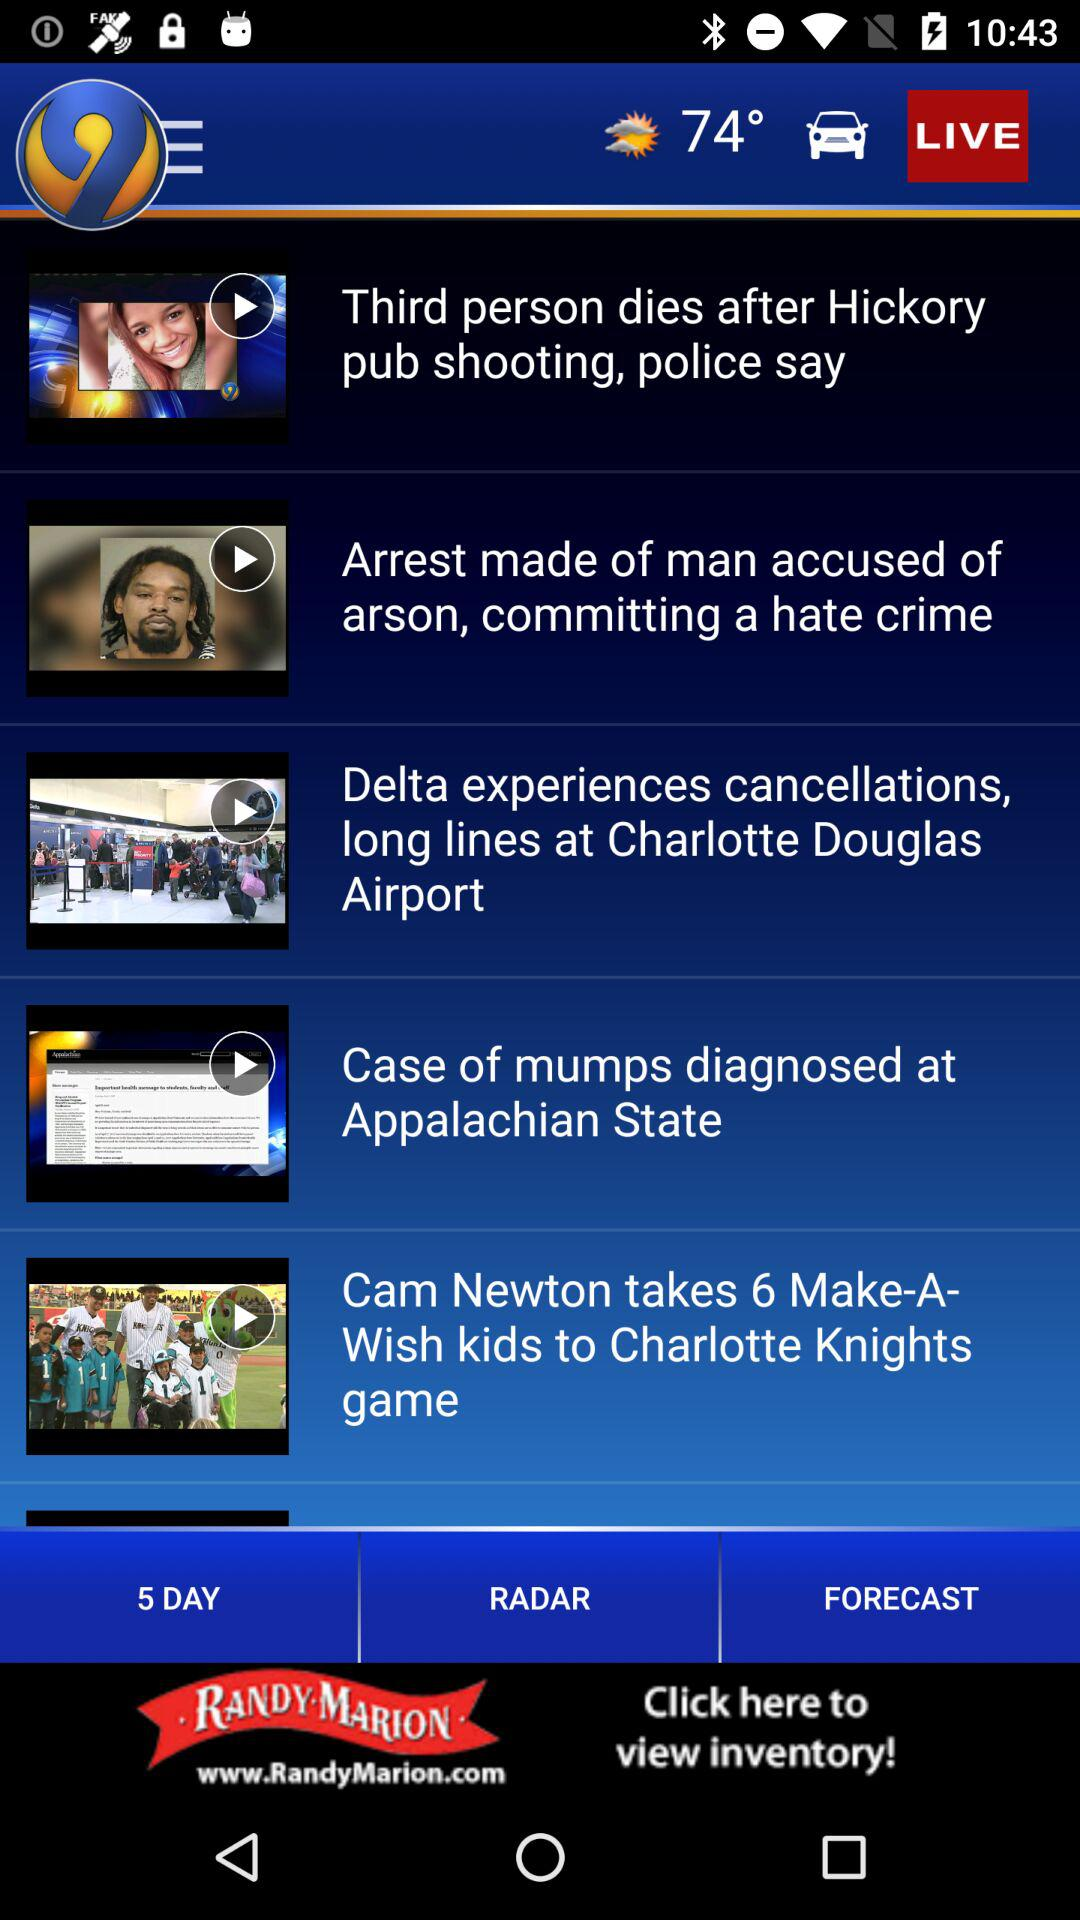What is the temperature? The temperature is 74°. 